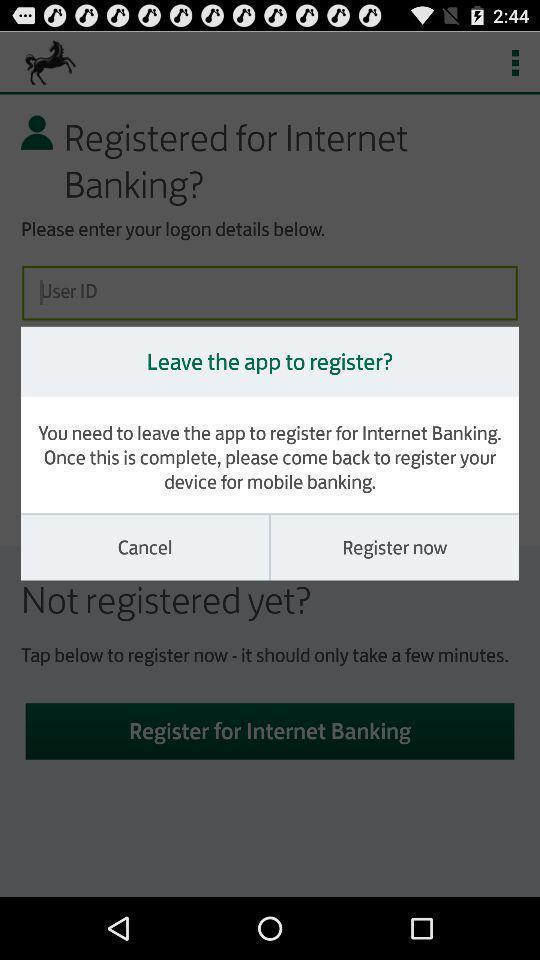Please provide a description for this image. Popup to register in the banking app. 